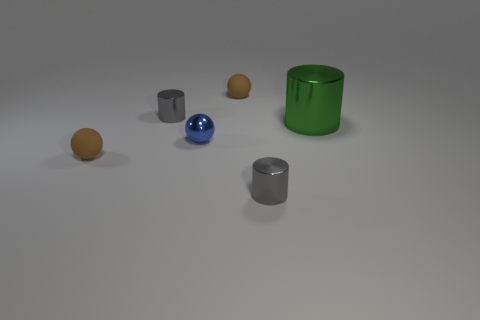Subtract all brown balls. How many were subtracted if there are1brown balls left? 1 Add 2 metal objects. How many objects exist? 8 Add 1 brown metallic spheres. How many brown metallic spheres exist? 1 Subtract 0 purple blocks. How many objects are left? 6 Subtract all green matte spheres. Subtract all gray objects. How many objects are left? 4 Add 3 tiny metal spheres. How many tiny metal spheres are left? 4 